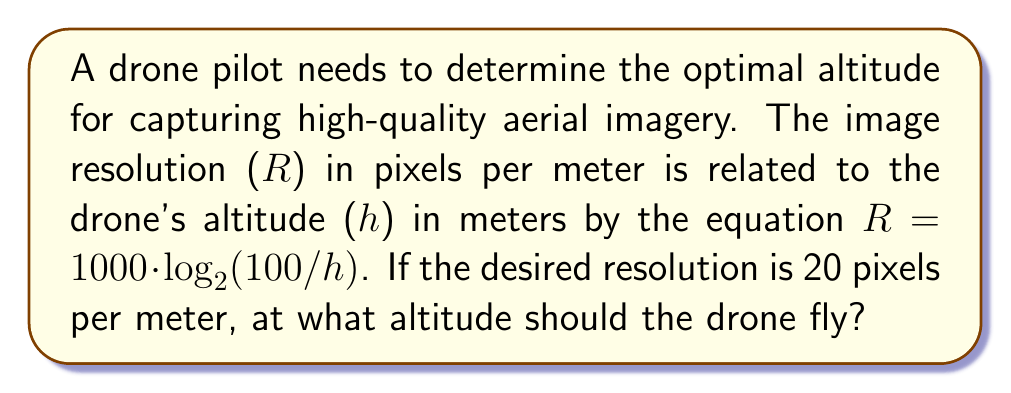Could you help me with this problem? Let's approach this step-by-step:

1) We're given the equation: $R = 1000 \cdot \log_{2}(100/h)$

2) We know that R = 20 pixels per meter, so we can substitute this:
   
   $20 = 1000 \cdot \log_{2}(100/h)$

3) First, let's divide both sides by 1000:
   
   $0.02 = \log_{2}(100/h)$

4) Now, we can apply $2^x$ to both sides to remove the logarithm:
   
   $2^{0.02} = 100/h$

5) Let's calculate $2^{0.02}$:
   
   $2^{0.02} \approx 1.0139$

6) So our equation is now:
   
   $1.0139 = 100/h$

7) Multiply both sides by h:
   
   $1.0139h = 100$

8) Finally, divide both sides by 1.0139:
   
   $h = 100/1.0139 \approx 98.63$

Therefore, the drone should fly at an altitude of approximately 98.63 meters to achieve a resolution of 20 pixels per meter.
Answer: 98.63 meters 